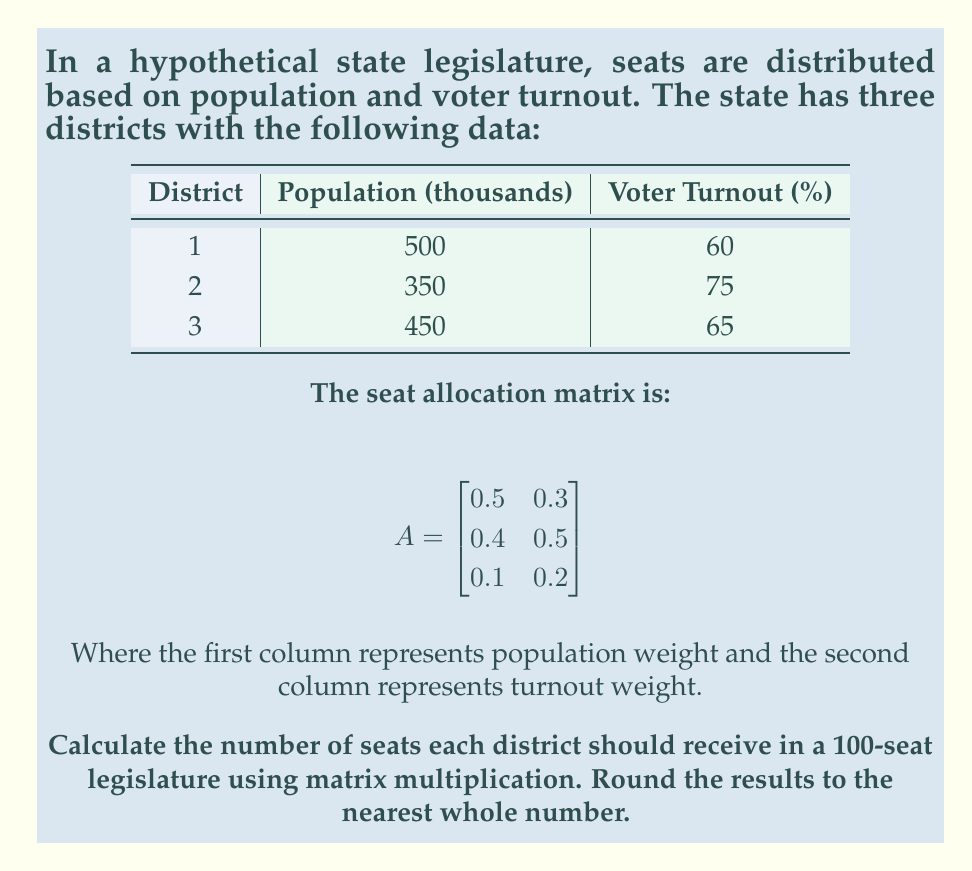Give your solution to this math problem. Let's approach this step-by-step:

1) First, we need to create a matrix with our district data. Let's call it D:

   $$D = \begin{bmatrix}
   500 & 60 \\
   350 & 75 \\
   450 & 65
   \end{bmatrix}$$

2) Now, we need to multiply D by A to get our seat distribution:

   $$S = D \times A$$

3) Let's perform the matrix multiplication:

   $$S = \begin{bmatrix}
   500 & 60 \\
   350 & 75 \\
   450 & 65
   \end{bmatrix} \times 
   \begin{bmatrix}
   0.5 & 0.3 \\
   0.4 & 0.5
   \end{bmatrix}$$

4) Multiplying these matrices:

   $$S = \begin{bmatrix}
   (500 \times 0.5 + 60 \times 0.4) & (500 \times 0.3 + 60 \times 0.5) \\
   (350 \times 0.5 + 75 \times 0.4) & (350 \times 0.3 + 75 \times 0.5) \\
   (450 \times 0.5 + 65 \times 0.4) & (450 \times 0.3 + 65 \times 0.5)
   \end{bmatrix}$$

5) Calculating each element:

   $$S = \begin{bmatrix}
   274 & 180 \\
   205 & 142.5 \\
   251 & 167.5
   \end{bmatrix}$$

6) To get the final seat distribution, we need to sum each row and then normalize to 100 seats:

   Total = 274 + 180 + 205 + 142.5 + 251 + 167.5 = 1220

   District 1: $(274 + 180) / 1220 \times 100 \approx 37.21$
   District 2: $(205 + 142.5) / 1220 \times 100 \approx 28.48$
   District 3: $(251 + 167.5) / 1220 \times 100 \approx 34.30$

7) Rounding to the nearest whole number:

   District 1: 37 seats
   District 2: 28 seats
   District 3: 34 seats
Answer: District 1: 37 seats, District 2: 28 seats, District 3: 34 seats 